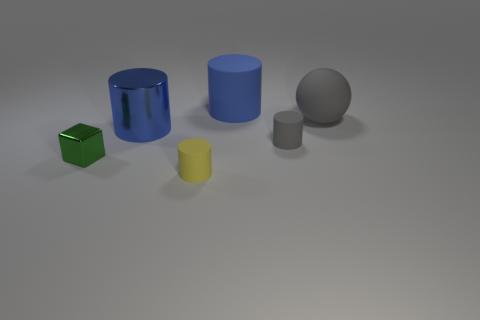There is a large object on the right side of the big cylinder that is behind the blue shiny object; what number of cylinders are in front of it?
Provide a succinct answer. 3. There is a gray object that is behind the small gray thing; how big is it?
Ensure brevity in your answer.  Large. Do the big thing on the left side of the blue rubber object and the blue rubber thing have the same shape?
Offer a very short reply. Yes. There is a tiny gray object that is the same shape as the tiny yellow rubber thing; what material is it?
Ensure brevity in your answer.  Rubber. Are any green blocks visible?
Your answer should be compact. Yes. The big cylinder that is in front of the blue object to the right of the matte object to the left of the blue matte thing is made of what material?
Keep it short and to the point. Metal. There is a small gray thing; is its shape the same as the large blue object that is in front of the large blue matte thing?
Make the answer very short. Yes. How many large blue matte things are the same shape as the yellow rubber object?
Your response must be concise. 1. What is the shape of the tiny yellow matte thing?
Provide a short and direct response. Cylinder. There is a gray thing that is left of the gray rubber sphere that is behind the tiny green metal cube; what size is it?
Provide a short and direct response. Small. 